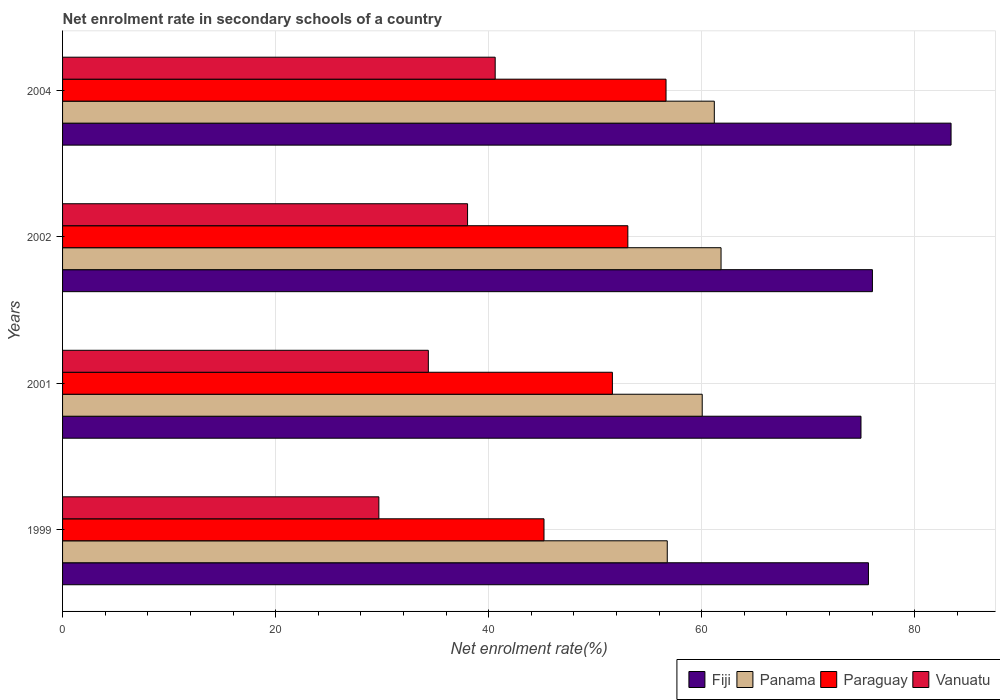How many groups of bars are there?
Provide a succinct answer. 4. Are the number of bars per tick equal to the number of legend labels?
Make the answer very short. Yes. How many bars are there on the 2nd tick from the bottom?
Provide a succinct answer. 4. What is the net enrolment rate in secondary schools in Panama in 2004?
Give a very brief answer. 61.18. Across all years, what is the maximum net enrolment rate in secondary schools in Paraguay?
Your answer should be very brief. 56.65. Across all years, what is the minimum net enrolment rate in secondary schools in Vanuatu?
Your response must be concise. 29.69. In which year was the net enrolment rate in secondary schools in Fiji maximum?
Offer a terse response. 2004. In which year was the net enrolment rate in secondary schools in Paraguay minimum?
Your response must be concise. 1999. What is the total net enrolment rate in secondary schools in Fiji in the graph?
Provide a succinct answer. 310.03. What is the difference between the net enrolment rate in secondary schools in Panama in 1999 and that in 2001?
Offer a very short reply. -3.28. What is the difference between the net enrolment rate in secondary schools in Fiji in 2004 and the net enrolment rate in secondary schools in Paraguay in 1999?
Make the answer very short. 38.21. What is the average net enrolment rate in secondary schools in Paraguay per year?
Make the answer very short. 51.63. In the year 1999, what is the difference between the net enrolment rate in secondary schools in Fiji and net enrolment rate in secondary schools in Paraguay?
Offer a terse response. 30.46. In how many years, is the net enrolment rate in secondary schools in Vanuatu greater than 28 %?
Offer a terse response. 4. What is the ratio of the net enrolment rate in secondary schools in Paraguay in 1999 to that in 2004?
Provide a short and direct response. 0.8. Is the net enrolment rate in secondary schools in Paraguay in 1999 less than that in 2002?
Ensure brevity in your answer.  Yes. What is the difference between the highest and the second highest net enrolment rate in secondary schools in Panama?
Your response must be concise. 0.63. What is the difference between the highest and the lowest net enrolment rate in secondary schools in Vanuatu?
Your response must be concise. 10.92. In how many years, is the net enrolment rate in secondary schools in Paraguay greater than the average net enrolment rate in secondary schools in Paraguay taken over all years?
Keep it short and to the point. 2. Is the sum of the net enrolment rate in secondary schools in Paraguay in 2002 and 2004 greater than the maximum net enrolment rate in secondary schools in Panama across all years?
Make the answer very short. Yes. What does the 1st bar from the top in 1999 represents?
Your answer should be very brief. Vanuatu. What does the 4th bar from the bottom in 2001 represents?
Give a very brief answer. Vanuatu. How many bars are there?
Keep it short and to the point. 16. Are all the bars in the graph horizontal?
Your answer should be very brief. Yes. How many years are there in the graph?
Keep it short and to the point. 4. Are the values on the major ticks of X-axis written in scientific E-notation?
Offer a terse response. No. Does the graph contain any zero values?
Keep it short and to the point. No. Does the graph contain grids?
Your response must be concise. Yes. What is the title of the graph?
Ensure brevity in your answer.  Net enrolment rate in secondary schools of a country. Does "St. Lucia" appear as one of the legend labels in the graph?
Offer a very short reply. No. What is the label or title of the X-axis?
Your answer should be very brief. Net enrolment rate(%). What is the Net enrolment rate(%) of Fiji in 1999?
Provide a short and direct response. 75.65. What is the Net enrolment rate(%) of Panama in 1999?
Offer a terse response. 56.77. What is the Net enrolment rate(%) in Paraguay in 1999?
Ensure brevity in your answer.  45.19. What is the Net enrolment rate(%) in Vanuatu in 1999?
Provide a succinct answer. 29.69. What is the Net enrolment rate(%) of Fiji in 2001?
Provide a short and direct response. 74.95. What is the Net enrolment rate(%) in Panama in 2001?
Your response must be concise. 60.05. What is the Net enrolment rate(%) in Paraguay in 2001?
Offer a very short reply. 51.61. What is the Net enrolment rate(%) of Vanuatu in 2001?
Your answer should be very brief. 34.34. What is the Net enrolment rate(%) in Fiji in 2002?
Provide a succinct answer. 76.02. What is the Net enrolment rate(%) in Panama in 2002?
Provide a short and direct response. 61.81. What is the Net enrolment rate(%) of Paraguay in 2002?
Ensure brevity in your answer.  53.07. What is the Net enrolment rate(%) in Vanuatu in 2002?
Give a very brief answer. 38.02. What is the Net enrolment rate(%) of Fiji in 2004?
Provide a short and direct response. 83.41. What is the Net enrolment rate(%) of Panama in 2004?
Give a very brief answer. 61.18. What is the Net enrolment rate(%) in Paraguay in 2004?
Make the answer very short. 56.65. What is the Net enrolment rate(%) in Vanuatu in 2004?
Ensure brevity in your answer.  40.61. Across all years, what is the maximum Net enrolment rate(%) in Fiji?
Offer a very short reply. 83.41. Across all years, what is the maximum Net enrolment rate(%) in Panama?
Offer a terse response. 61.81. Across all years, what is the maximum Net enrolment rate(%) of Paraguay?
Make the answer very short. 56.65. Across all years, what is the maximum Net enrolment rate(%) in Vanuatu?
Ensure brevity in your answer.  40.61. Across all years, what is the minimum Net enrolment rate(%) in Fiji?
Ensure brevity in your answer.  74.95. Across all years, what is the minimum Net enrolment rate(%) of Panama?
Your response must be concise. 56.77. Across all years, what is the minimum Net enrolment rate(%) in Paraguay?
Provide a succinct answer. 45.19. Across all years, what is the minimum Net enrolment rate(%) in Vanuatu?
Your answer should be very brief. 29.69. What is the total Net enrolment rate(%) in Fiji in the graph?
Keep it short and to the point. 310.03. What is the total Net enrolment rate(%) of Panama in the graph?
Provide a short and direct response. 239.81. What is the total Net enrolment rate(%) of Paraguay in the graph?
Your answer should be very brief. 206.52. What is the total Net enrolment rate(%) of Vanuatu in the graph?
Make the answer very short. 142.66. What is the difference between the Net enrolment rate(%) in Fiji in 1999 and that in 2001?
Your response must be concise. 0.7. What is the difference between the Net enrolment rate(%) in Panama in 1999 and that in 2001?
Provide a succinct answer. -3.28. What is the difference between the Net enrolment rate(%) in Paraguay in 1999 and that in 2001?
Provide a short and direct response. -6.42. What is the difference between the Net enrolment rate(%) of Vanuatu in 1999 and that in 2001?
Your answer should be very brief. -4.64. What is the difference between the Net enrolment rate(%) of Fiji in 1999 and that in 2002?
Ensure brevity in your answer.  -0.37. What is the difference between the Net enrolment rate(%) of Panama in 1999 and that in 2002?
Your response must be concise. -5.05. What is the difference between the Net enrolment rate(%) of Paraguay in 1999 and that in 2002?
Your answer should be compact. -7.87. What is the difference between the Net enrolment rate(%) in Vanuatu in 1999 and that in 2002?
Ensure brevity in your answer.  -8.33. What is the difference between the Net enrolment rate(%) in Fiji in 1999 and that in 2004?
Keep it short and to the point. -7.76. What is the difference between the Net enrolment rate(%) of Panama in 1999 and that in 2004?
Give a very brief answer. -4.42. What is the difference between the Net enrolment rate(%) in Paraguay in 1999 and that in 2004?
Ensure brevity in your answer.  -11.46. What is the difference between the Net enrolment rate(%) of Vanuatu in 1999 and that in 2004?
Offer a very short reply. -10.92. What is the difference between the Net enrolment rate(%) of Fiji in 2001 and that in 2002?
Your response must be concise. -1.07. What is the difference between the Net enrolment rate(%) in Panama in 2001 and that in 2002?
Provide a succinct answer. -1.77. What is the difference between the Net enrolment rate(%) of Paraguay in 2001 and that in 2002?
Your answer should be compact. -1.45. What is the difference between the Net enrolment rate(%) of Vanuatu in 2001 and that in 2002?
Provide a short and direct response. -3.68. What is the difference between the Net enrolment rate(%) of Fiji in 2001 and that in 2004?
Provide a succinct answer. -8.46. What is the difference between the Net enrolment rate(%) in Panama in 2001 and that in 2004?
Your answer should be very brief. -1.14. What is the difference between the Net enrolment rate(%) in Paraguay in 2001 and that in 2004?
Give a very brief answer. -5.04. What is the difference between the Net enrolment rate(%) of Vanuatu in 2001 and that in 2004?
Your answer should be very brief. -6.28. What is the difference between the Net enrolment rate(%) of Fiji in 2002 and that in 2004?
Give a very brief answer. -7.38. What is the difference between the Net enrolment rate(%) of Panama in 2002 and that in 2004?
Offer a very short reply. 0.63. What is the difference between the Net enrolment rate(%) of Paraguay in 2002 and that in 2004?
Offer a terse response. -3.58. What is the difference between the Net enrolment rate(%) in Vanuatu in 2002 and that in 2004?
Give a very brief answer. -2.59. What is the difference between the Net enrolment rate(%) of Fiji in 1999 and the Net enrolment rate(%) of Panama in 2001?
Your answer should be compact. 15.6. What is the difference between the Net enrolment rate(%) of Fiji in 1999 and the Net enrolment rate(%) of Paraguay in 2001?
Provide a succinct answer. 24.04. What is the difference between the Net enrolment rate(%) in Fiji in 1999 and the Net enrolment rate(%) in Vanuatu in 2001?
Make the answer very short. 41.31. What is the difference between the Net enrolment rate(%) of Panama in 1999 and the Net enrolment rate(%) of Paraguay in 2001?
Provide a succinct answer. 5.15. What is the difference between the Net enrolment rate(%) of Panama in 1999 and the Net enrolment rate(%) of Vanuatu in 2001?
Keep it short and to the point. 22.43. What is the difference between the Net enrolment rate(%) of Paraguay in 1999 and the Net enrolment rate(%) of Vanuatu in 2001?
Your answer should be very brief. 10.86. What is the difference between the Net enrolment rate(%) in Fiji in 1999 and the Net enrolment rate(%) in Panama in 2002?
Make the answer very short. 13.84. What is the difference between the Net enrolment rate(%) in Fiji in 1999 and the Net enrolment rate(%) in Paraguay in 2002?
Ensure brevity in your answer.  22.59. What is the difference between the Net enrolment rate(%) of Fiji in 1999 and the Net enrolment rate(%) of Vanuatu in 2002?
Ensure brevity in your answer.  37.63. What is the difference between the Net enrolment rate(%) in Panama in 1999 and the Net enrolment rate(%) in Paraguay in 2002?
Keep it short and to the point. 3.7. What is the difference between the Net enrolment rate(%) of Panama in 1999 and the Net enrolment rate(%) of Vanuatu in 2002?
Your answer should be compact. 18.75. What is the difference between the Net enrolment rate(%) in Paraguay in 1999 and the Net enrolment rate(%) in Vanuatu in 2002?
Give a very brief answer. 7.18. What is the difference between the Net enrolment rate(%) in Fiji in 1999 and the Net enrolment rate(%) in Panama in 2004?
Offer a very short reply. 14.47. What is the difference between the Net enrolment rate(%) in Fiji in 1999 and the Net enrolment rate(%) in Paraguay in 2004?
Your answer should be very brief. 19. What is the difference between the Net enrolment rate(%) of Fiji in 1999 and the Net enrolment rate(%) of Vanuatu in 2004?
Offer a terse response. 35.04. What is the difference between the Net enrolment rate(%) of Panama in 1999 and the Net enrolment rate(%) of Paraguay in 2004?
Offer a terse response. 0.12. What is the difference between the Net enrolment rate(%) of Panama in 1999 and the Net enrolment rate(%) of Vanuatu in 2004?
Your response must be concise. 16.15. What is the difference between the Net enrolment rate(%) of Paraguay in 1999 and the Net enrolment rate(%) of Vanuatu in 2004?
Your response must be concise. 4.58. What is the difference between the Net enrolment rate(%) in Fiji in 2001 and the Net enrolment rate(%) in Panama in 2002?
Keep it short and to the point. 13.14. What is the difference between the Net enrolment rate(%) in Fiji in 2001 and the Net enrolment rate(%) in Paraguay in 2002?
Provide a short and direct response. 21.88. What is the difference between the Net enrolment rate(%) of Fiji in 2001 and the Net enrolment rate(%) of Vanuatu in 2002?
Your answer should be very brief. 36.93. What is the difference between the Net enrolment rate(%) of Panama in 2001 and the Net enrolment rate(%) of Paraguay in 2002?
Offer a terse response. 6.98. What is the difference between the Net enrolment rate(%) in Panama in 2001 and the Net enrolment rate(%) in Vanuatu in 2002?
Provide a short and direct response. 22.03. What is the difference between the Net enrolment rate(%) of Paraguay in 2001 and the Net enrolment rate(%) of Vanuatu in 2002?
Keep it short and to the point. 13.6. What is the difference between the Net enrolment rate(%) of Fiji in 2001 and the Net enrolment rate(%) of Panama in 2004?
Make the answer very short. 13.77. What is the difference between the Net enrolment rate(%) in Fiji in 2001 and the Net enrolment rate(%) in Paraguay in 2004?
Make the answer very short. 18.3. What is the difference between the Net enrolment rate(%) in Fiji in 2001 and the Net enrolment rate(%) in Vanuatu in 2004?
Your response must be concise. 34.34. What is the difference between the Net enrolment rate(%) in Panama in 2001 and the Net enrolment rate(%) in Paraguay in 2004?
Your answer should be compact. 3.4. What is the difference between the Net enrolment rate(%) in Panama in 2001 and the Net enrolment rate(%) in Vanuatu in 2004?
Your response must be concise. 19.43. What is the difference between the Net enrolment rate(%) in Paraguay in 2001 and the Net enrolment rate(%) in Vanuatu in 2004?
Keep it short and to the point. 11. What is the difference between the Net enrolment rate(%) of Fiji in 2002 and the Net enrolment rate(%) of Panama in 2004?
Provide a short and direct response. 14.84. What is the difference between the Net enrolment rate(%) in Fiji in 2002 and the Net enrolment rate(%) in Paraguay in 2004?
Keep it short and to the point. 19.37. What is the difference between the Net enrolment rate(%) of Fiji in 2002 and the Net enrolment rate(%) of Vanuatu in 2004?
Your answer should be compact. 35.41. What is the difference between the Net enrolment rate(%) in Panama in 2002 and the Net enrolment rate(%) in Paraguay in 2004?
Keep it short and to the point. 5.16. What is the difference between the Net enrolment rate(%) in Panama in 2002 and the Net enrolment rate(%) in Vanuatu in 2004?
Make the answer very short. 21.2. What is the difference between the Net enrolment rate(%) of Paraguay in 2002 and the Net enrolment rate(%) of Vanuatu in 2004?
Keep it short and to the point. 12.45. What is the average Net enrolment rate(%) of Fiji per year?
Your answer should be very brief. 77.51. What is the average Net enrolment rate(%) in Panama per year?
Offer a terse response. 59.95. What is the average Net enrolment rate(%) in Paraguay per year?
Provide a short and direct response. 51.63. What is the average Net enrolment rate(%) of Vanuatu per year?
Provide a short and direct response. 35.66. In the year 1999, what is the difference between the Net enrolment rate(%) in Fiji and Net enrolment rate(%) in Panama?
Give a very brief answer. 18.89. In the year 1999, what is the difference between the Net enrolment rate(%) of Fiji and Net enrolment rate(%) of Paraguay?
Give a very brief answer. 30.46. In the year 1999, what is the difference between the Net enrolment rate(%) of Fiji and Net enrolment rate(%) of Vanuatu?
Ensure brevity in your answer.  45.96. In the year 1999, what is the difference between the Net enrolment rate(%) of Panama and Net enrolment rate(%) of Paraguay?
Provide a succinct answer. 11.57. In the year 1999, what is the difference between the Net enrolment rate(%) of Panama and Net enrolment rate(%) of Vanuatu?
Your response must be concise. 27.07. In the year 1999, what is the difference between the Net enrolment rate(%) in Paraguay and Net enrolment rate(%) in Vanuatu?
Your answer should be very brief. 15.5. In the year 2001, what is the difference between the Net enrolment rate(%) of Fiji and Net enrolment rate(%) of Panama?
Offer a terse response. 14.9. In the year 2001, what is the difference between the Net enrolment rate(%) of Fiji and Net enrolment rate(%) of Paraguay?
Make the answer very short. 23.34. In the year 2001, what is the difference between the Net enrolment rate(%) in Fiji and Net enrolment rate(%) in Vanuatu?
Make the answer very short. 40.61. In the year 2001, what is the difference between the Net enrolment rate(%) of Panama and Net enrolment rate(%) of Paraguay?
Offer a very short reply. 8.43. In the year 2001, what is the difference between the Net enrolment rate(%) of Panama and Net enrolment rate(%) of Vanuatu?
Your response must be concise. 25.71. In the year 2001, what is the difference between the Net enrolment rate(%) in Paraguay and Net enrolment rate(%) in Vanuatu?
Offer a very short reply. 17.28. In the year 2002, what is the difference between the Net enrolment rate(%) of Fiji and Net enrolment rate(%) of Panama?
Ensure brevity in your answer.  14.21. In the year 2002, what is the difference between the Net enrolment rate(%) in Fiji and Net enrolment rate(%) in Paraguay?
Your answer should be very brief. 22.96. In the year 2002, what is the difference between the Net enrolment rate(%) in Fiji and Net enrolment rate(%) in Vanuatu?
Your answer should be compact. 38.01. In the year 2002, what is the difference between the Net enrolment rate(%) of Panama and Net enrolment rate(%) of Paraguay?
Keep it short and to the point. 8.75. In the year 2002, what is the difference between the Net enrolment rate(%) of Panama and Net enrolment rate(%) of Vanuatu?
Ensure brevity in your answer.  23.8. In the year 2002, what is the difference between the Net enrolment rate(%) of Paraguay and Net enrolment rate(%) of Vanuatu?
Keep it short and to the point. 15.05. In the year 2004, what is the difference between the Net enrolment rate(%) in Fiji and Net enrolment rate(%) in Panama?
Offer a very short reply. 22.22. In the year 2004, what is the difference between the Net enrolment rate(%) in Fiji and Net enrolment rate(%) in Paraguay?
Provide a succinct answer. 26.76. In the year 2004, what is the difference between the Net enrolment rate(%) of Fiji and Net enrolment rate(%) of Vanuatu?
Offer a very short reply. 42.79. In the year 2004, what is the difference between the Net enrolment rate(%) in Panama and Net enrolment rate(%) in Paraguay?
Your response must be concise. 4.53. In the year 2004, what is the difference between the Net enrolment rate(%) of Panama and Net enrolment rate(%) of Vanuatu?
Offer a terse response. 20.57. In the year 2004, what is the difference between the Net enrolment rate(%) in Paraguay and Net enrolment rate(%) in Vanuatu?
Keep it short and to the point. 16.04. What is the ratio of the Net enrolment rate(%) in Fiji in 1999 to that in 2001?
Your response must be concise. 1.01. What is the ratio of the Net enrolment rate(%) in Panama in 1999 to that in 2001?
Provide a succinct answer. 0.95. What is the ratio of the Net enrolment rate(%) in Paraguay in 1999 to that in 2001?
Give a very brief answer. 0.88. What is the ratio of the Net enrolment rate(%) in Vanuatu in 1999 to that in 2001?
Keep it short and to the point. 0.86. What is the ratio of the Net enrolment rate(%) of Fiji in 1999 to that in 2002?
Make the answer very short. 1. What is the ratio of the Net enrolment rate(%) in Panama in 1999 to that in 2002?
Your answer should be compact. 0.92. What is the ratio of the Net enrolment rate(%) of Paraguay in 1999 to that in 2002?
Offer a terse response. 0.85. What is the ratio of the Net enrolment rate(%) in Vanuatu in 1999 to that in 2002?
Provide a short and direct response. 0.78. What is the ratio of the Net enrolment rate(%) of Fiji in 1999 to that in 2004?
Provide a short and direct response. 0.91. What is the ratio of the Net enrolment rate(%) of Panama in 1999 to that in 2004?
Give a very brief answer. 0.93. What is the ratio of the Net enrolment rate(%) in Paraguay in 1999 to that in 2004?
Your answer should be compact. 0.8. What is the ratio of the Net enrolment rate(%) of Vanuatu in 1999 to that in 2004?
Your response must be concise. 0.73. What is the ratio of the Net enrolment rate(%) in Fiji in 2001 to that in 2002?
Your answer should be very brief. 0.99. What is the ratio of the Net enrolment rate(%) of Panama in 2001 to that in 2002?
Give a very brief answer. 0.97. What is the ratio of the Net enrolment rate(%) in Paraguay in 2001 to that in 2002?
Offer a terse response. 0.97. What is the ratio of the Net enrolment rate(%) in Vanuatu in 2001 to that in 2002?
Offer a very short reply. 0.9. What is the ratio of the Net enrolment rate(%) in Fiji in 2001 to that in 2004?
Provide a succinct answer. 0.9. What is the ratio of the Net enrolment rate(%) in Panama in 2001 to that in 2004?
Offer a very short reply. 0.98. What is the ratio of the Net enrolment rate(%) in Paraguay in 2001 to that in 2004?
Your response must be concise. 0.91. What is the ratio of the Net enrolment rate(%) of Vanuatu in 2001 to that in 2004?
Your answer should be compact. 0.85. What is the ratio of the Net enrolment rate(%) in Fiji in 2002 to that in 2004?
Provide a short and direct response. 0.91. What is the ratio of the Net enrolment rate(%) in Panama in 2002 to that in 2004?
Your response must be concise. 1.01. What is the ratio of the Net enrolment rate(%) in Paraguay in 2002 to that in 2004?
Ensure brevity in your answer.  0.94. What is the ratio of the Net enrolment rate(%) in Vanuatu in 2002 to that in 2004?
Give a very brief answer. 0.94. What is the difference between the highest and the second highest Net enrolment rate(%) of Fiji?
Your response must be concise. 7.38. What is the difference between the highest and the second highest Net enrolment rate(%) in Panama?
Provide a short and direct response. 0.63. What is the difference between the highest and the second highest Net enrolment rate(%) in Paraguay?
Offer a terse response. 3.58. What is the difference between the highest and the second highest Net enrolment rate(%) in Vanuatu?
Give a very brief answer. 2.59. What is the difference between the highest and the lowest Net enrolment rate(%) of Fiji?
Provide a short and direct response. 8.46. What is the difference between the highest and the lowest Net enrolment rate(%) of Panama?
Give a very brief answer. 5.05. What is the difference between the highest and the lowest Net enrolment rate(%) of Paraguay?
Ensure brevity in your answer.  11.46. What is the difference between the highest and the lowest Net enrolment rate(%) of Vanuatu?
Provide a short and direct response. 10.92. 